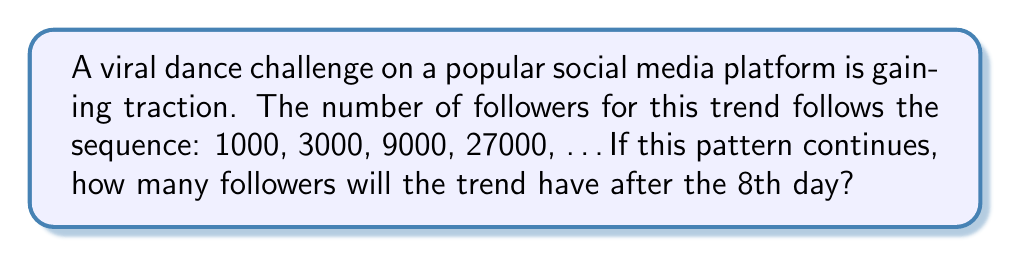Show me your answer to this math problem. Let's approach this step-by-step:

1) First, we need to identify the pattern in the given sequence:
   1000, 3000, 9000, 27000, ...

2) We can see that each term is being multiplied by 3 to get the next term:
   1000 * 3 = 3000
   3000 * 3 = 9000
   9000 * 3 = 27000

3) This means we have a geometric sequence with a common ratio of 3.

4) The general formula for the nth term of a geometric sequence is:
   $$a_n = a_1 * r^{n-1}$$
   where $a_1$ is the first term, $r$ is the common ratio, and $n$ is the position of the term.

5) In this case:
   $a_1 = 1000$ (first term)
   $r = 3$ (common ratio)
   We need to find $a_8$ (8th term)

6) Plugging these into our formula:
   $$a_8 = 1000 * 3^{8-1} = 1000 * 3^7$$

7) Calculate:
   $$1000 * 3^7 = 1000 * 2187 = 2,187,000$$

Therefore, after the 8th day, the trend will have 2,187,000 followers.
Answer: 2,187,000 followers 